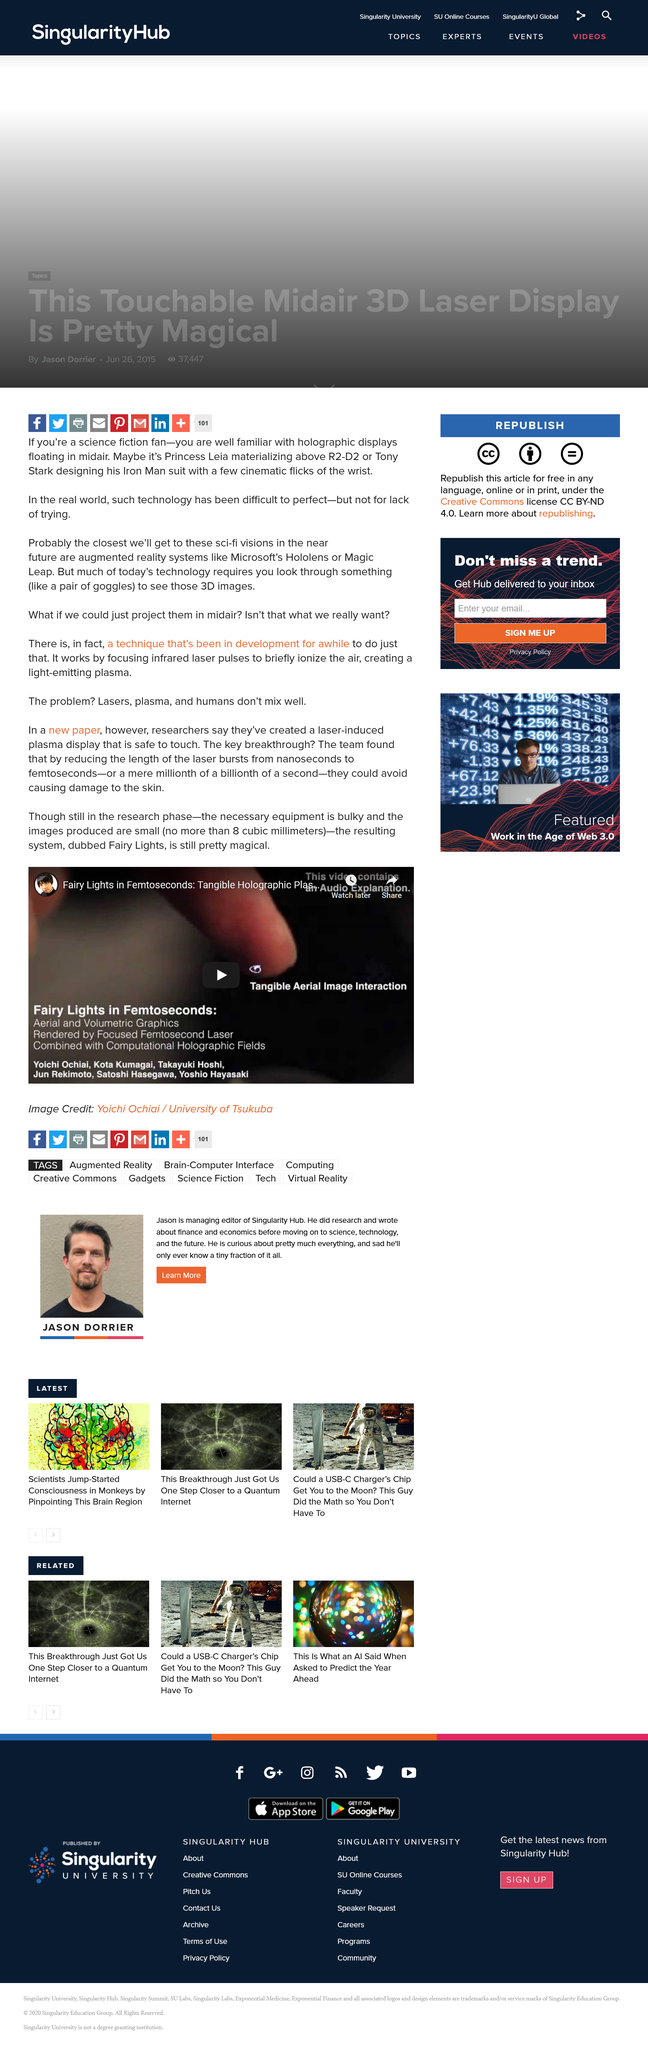Highlight a few significant elements in this photo. Lasers, plasma, and humans do not mix well. The image "Fairy Lights in Femtoseconds," credited to Yoichi Ochiai from the University of Tsukuba, depicts a fascinating visual representation of light phenomena that occur in femtoseconds. The images produced by the new display are incredibly small, with a maximum dimension of just 8 cubic millimeters. 